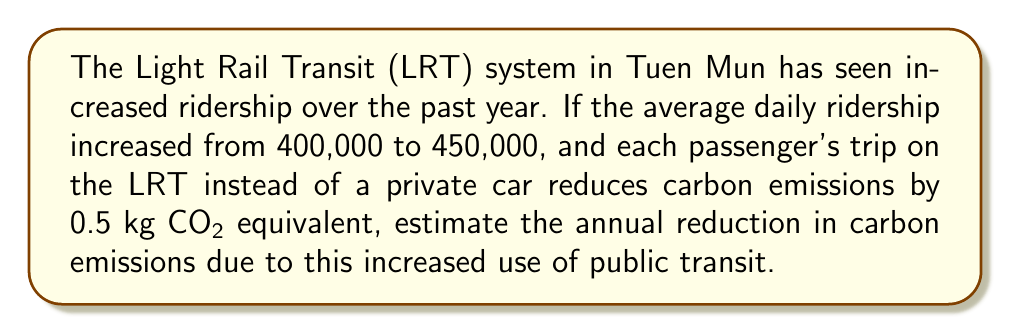Solve this math problem. Let's approach this step-by-step:

1) First, calculate the increase in daily ridership:
   $450,000 - 400,000 = 50,000$ additional riders per day

2) Each rider reduces emissions by 0.5 kg CO₂ equivalent:
   $50,000 \times 0.5 = 25,000$ kg CO₂ equivalent reduced per day

3) To calculate the annual reduction, we multiply by the number of days in a year:
   $25,000 \times 365 = 9,125,000$ kg CO₂ equivalent per year

4) Convert kg to metric tons:
   $\frac{9,125,000}{1000} = 9,125$ metric tons CO₂ equivalent per year

Therefore, the estimated annual reduction in carbon emissions due to increased use of the Tuen Mun LRT is 9,125 metric tons CO₂ equivalent.
Answer: 9,125 metric tons CO₂ equivalent 